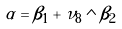Convert formula to latex. <formula><loc_0><loc_0><loc_500><loc_500>\alpha = \beta _ { 1 } + \nu _ { 8 } \wedge \beta _ { 2 }</formula> 